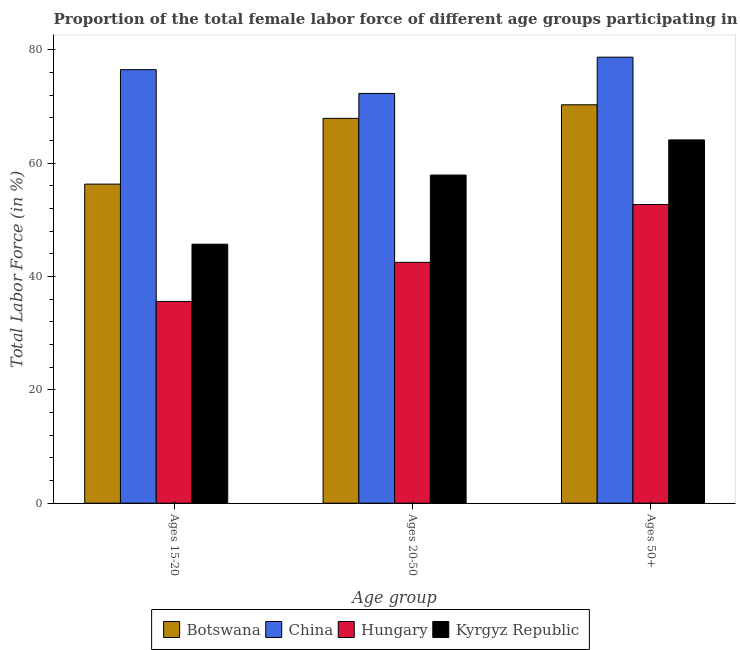How many different coloured bars are there?
Offer a terse response. 4. How many groups of bars are there?
Your answer should be very brief. 3. Are the number of bars per tick equal to the number of legend labels?
Provide a succinct answer. Yes. How many bars are there on the 1st tick from the right?
Offer a very short reply. 4. What is the label of the 1st group of bars from the left?
Your answer should be very brief. Ages 15-20. What is the percentage of female labor force above age 50 in China?
Offer a terse response. 78.7. Across all countries, what is the maximum percentage of female labor force above age 50?
Offer a terse response. 78.7. Across all countries, what is the minimum percentage of female labor force above age 50?
Your answer should be very brief. 52.7. In which country was the percentage of female labor force within the age group 15-20 maximum?
Provide a short and direct response. China. In which country was the percentage of female labor force within the age group 20-50 minimum?
Keep it short and to the point. Hungary. What is the total percentage of female labor force within the age group 15-20 in the graph?
Make the answer very short. 214.1. What is the difference between the percentage of female labor force within the age group 20-50 in Kyrgyz Republic and that in Hungary?
Keep it short and to the point. 15.4. What is the difference between the percentage of female labor force within the age group 20-50 in Kyrgyz Republic and the percentage of female labor force above age 50 in Hungary?
Your answer should be compact. 5.2. What is the average percentage of female labor force within the age group 20-50 per country?
Your answer should be very brief. 60.15. What is the difference between the percentage of female labor force above age 50 and percentage of female labor force within the age group 15-20 in Botswana?
Provide a succinct answer. 14. What is the ratio of the percentage of female labor force above age 50 in Kyrgyz Republic to that in Botswana?
Make the answer very short. 0.91. Is the percentage of female labor force within the age group 20-50 in Hungary less than that in Kyrgyz Republic?
Make the answer very short. Yes. What is the difference between the highest and the second highest percentage of female labor force above age 50?
Your answer should be compact. 8.4. What is the difference between the highest and the lowest percentage of female labor force above age 50?
Ensure brevity in your answer.  26. In how many countries, is the percentage of female labor force within the age group 20-50 greater than the average percentage of female labor force within the age group 20-50 taken over all countries?
Keep it short and to the point. 2. Is the sum of the percentage of female labor force within the age group 20-50 in Botswana and China greater than the maximum percentage of female labor force within the age group 15-20 across all countries?
Give a very brief answer. Yes. What does the 4th bar from the left in Ages 50+ represents?
Give a very brief answer. Kyrgyz Republic. What does the 3rd bar from the right in Ages 50+ represents?
Your response must be concise. China. How many countries are there in the graph?
Ensure brevity in your answer.  4. Does the graph contain any zero values?
Provide a succinct answer. No. How many legend labels are there?
Give a very brief answer. 4. How are the legend labels stacked?
Provide a short and direct response. Horizontal. What is the title of the graph?
Offer a very short reply. Proportion of the total female labor force of different age groups participating in production in 1994. Does "Cameroon" appear as one of the legend labels in the graph?
Provide a short and direct response. No. What is the label or title of the X-axis?
Your answer should be very brief. Age group. What is the Total Labor Force (in %) of Botswana in Ages 15-20?
Provide a succinct answer. 56.3. What is the Total Labor Force (in %) in China in Ages 15-20?
Give a very brief answer. 76.5. What is the Total Labor Force (in %) of Hungary in Ages 15-20?
Ensure brevity in your answer.  35.6. What is the Total Labor Force (in %) of Kyrgyz Republic in Ages 15-20?
Offer a terse response. 45.7. What is the Total Labor Force (in %) of Botswana in Ages 20-50?
Keep it short and to the point. 67.9. What is the Total Labor Force (in %) in China in Ages 20-50?
Give a very brief answer. 72.3. What is the Total Labor Force (in %) of Hungary in Ages 20-50?
Offer a terse response. 42.5. What is the Total Labor Force (in %) in Kyrgyz Republic in Ages 20-50?
Provide a short and direct response. 57.9. What is the Total Labor Force (in %) of Botswana in Ages 50+?
Provide a succinct answer. 70.3. What is the Total Labor Force (in %) in China in Ages 50+?
Ensure brevity in your answer.  78.7. What is the Total Labor Force (in %) in Hungary in Ages 50+?
Ensure brevity in your answer.  52.7. What is the Total Labor Force (in %) in Kyrgyz Republic in Ages 50+?
Provide a succinct answer. 64.1. Across all Age group, what is the maximum Total Labor Force (in %) of Botswana?
Your response must be concise. 70.3. Across all Age group, what is the maximum Total Labor Force (in %) in China?
Keep it short and to the point. 78.7. Across all Age group, what is the maximum Total Labor Force (in %) in Hungary?
Offer a terse response. 52.7. Across all Age group, what is the maximum Total Labor Force (in %) of Kyrgyz Republic?
Provide a short and direct response. 64.1. Across all Age group, what is the minimum Total Labor Force (in %) in Botswana?
Make the answer very short. 56.3. Across all Age group, what is the minimum Total Labor Force (in %) of China?
Make the answer very short. 72.3. Across all Age group, what is the minimum Total Labor Force (in %) in Hungary?
Offer a terse response. 35.6. Across all Age group, what is the minimum Total Labor Force (in %) of Kyrgyz Republic?
Your answer should be very brief. 45.7. What is the total Total Labor Force (in %) of Botswana in the graph?
Offer a terse response. 194.5. What is the total Total Labor Force (in %) of China in the graph?
Provide a short and direct response. 227.5. What is the total Total Labor Force (in %) in Hungary in the graph?
Your answer should be compact. 130.8. What is the total Total Labor Force (in %) of Kyrgyz Republic in the graph?
Provide a short and direct response. 167.7. What is the difference between the Total Labor Force (in %) of Hungary in Ages 15-20 and that in Ages 20-50?
Give a very brief answer. -6.9. What is the difference between the Total Labor Force (in %) of Kyrgyz Republic in Ages 15-20 and that in Ages 20-50?
Make the answer very short. -12.2. What is the difference between the Total Labor Force (in %) in China in Ages 15-20 and that in Ages 50+?
Your answer should be compact. -2.2. What is the difference between the Total Labor Force (in %) of Hungary in Ages 15-20 and that in Ages 50+?
Ensure brevity in your answer.  -17.1. What is the difference between the Total Labor Force (in %) of Kyrgyz Republic in Ages 15-20 and that in Ages 50+?
Your answer should be very brief. -18.4. What is the difference between the Total Labor Force (in %) in China in Ages 20-50 and that in Ages 50+?
Offer a terse response. -6.4. What is the difference between the Total Labor Force (in %) in Hungary in Ages 20-50 and that in Ages 50+?
Make the answer very short. -10.2. What is the difference between the Total Labor Force (in %) in Botswana in Ages 15-20 and the Total Labor Force (in %) in Kyrgyz Republic in Ages 20-50?
Your response must be concise. -1.6. What is the difference between the Total Labor Force (in %) of China in Ages 15-20 and the Total Labor Force (in %) of Kyrgyz Republic in Ages 20-50?
Give a very brief answer. 18.6. What is the difference between the Total Labor Force (in %) of Hungary in Ages 15-20 and the Total Labor Force (in %) of Kyrgyz Republic in Ages 20-50?
Make the answer very short. -22.3. What is the difference between the Total Labor Force (in %) in Botswana in Ages 15-20 and the Total Labor Force (in %) in China in Ages 50+?
Provide a succinct answer. -22.4. What is the difference between the Total Labor Force (in %) of Botswana in Ages 15-20 and the Total Labor Force (in %) of Hungary in Ages 50+?
Offer a terse response. 3.6. What is the difference between the Total Labor Force (in %) in Botswana in Ages 15-20 and the Total Labor Force (in %) in Kyrgyz Republic in Ages 50+?
Your response must be concise. -7.8. What is the difference between the Total Labor Force (in %) of China in Ages 15-20 and the Total Labor Force (in %) of Hungary in Ages 50+?
Provide a short and direct response. 23.8. What is the difference between the Total Labor Force (in %) of China in Ages 15-20 and the Total Labor Force (in %) of Kyrgyz Republic in Ages 50+?
Offer a terse response. 12.4. What is the difference between the Total Labor Force (in %) in Hungary in Ages 15-20 and the Total Labor Force (in %) in Kyrgyz Republic in Ages 50+?
Give a very brief answer. -28.5. What is the difference between the Total Labor Force (in %) of Botswana in Ages 20-50 and the Total Labor Force (in %) of China in Ages 50+?
Your answer should be compact. -10.8. What is the difference between the Total Labor Force (in %) in China in Ages 20-50 and the Total Labor Force (in %) in Hungary in Ages 50+?
Ensure brevity in your answer.  19.6. What is the difference between the Total Labor Force (in %) in Hungary in Ages 20-50 and the Total Labor Force (in %) in Kyrgyz Republic in Ages 50+?
Your answer should be compact. -21.6. What is the average Total Labor Force (in %) in Botswana per Age group?
Give a very brief answer. 64.83. What is the average Total Labor Force (in %) in China per Age group?
Give a very brief answer. 75.83. What is the average Total Labor Force (in %) in Hungary per Age group?
Your response must be concise. 43.6. What is the average Total Labor Force (in %) of Kyrgyz Republic per Age group?
Provide a succinct answer. 55.9. What is the difference between the Total Labor Force (in %) in Botswana and Total Labor Force (in %) in China in Ages 15-20?
Make the answer very short. -20.2. What is the difference between the Total Labor Force (in %) in Botswana and Total Labor Force (in %) in Hungary in Ages 15-20?
Offer a terse response. 20.7. What is the difference between the Total Labor Force (in %) in Botswana and Total Labor Force (in %) in Kyrgyz Republic in Ages 15-20?
Provide a succinct answer. 10.6. What is the difference between the Total Labor Force (in %) of China and Total Labor Force (in %) of Hungary in Ages 15-20?
Offer a terse response. 40.9. What is the difference between the Total Labor Force (in %) in China and Total Labor Force (in %) in Kyrgyz Republic in Ages 15-20?
Give a very brief answer. 30.8. What is the difference between the Total Labor Force (in %) in Botswana and Total Labor Force (in %) in China in Ages 20-50?
Your response must be concise. -4.4. What is the difference between the Total Labor Force (in %) of Botswana and Total Labor Force (in %) of Hungary in Ages 20-50?
Provide a succinct answer. 25.4. What is the difference between the Total Labor Force (in %) in Botswana and Total Labor Force (in %) in Kyrgyz Republic in Ages 20-50?
Provide a short and direct response. 10. What is the difference between the Total Labor Force (in %) in China and Total Labor Force (in %) in Hungary in Ages 20-50?
Your response must be concise. 29.8. What is the difference between the Total Labor Force (in %) in China and Total Labor Force (in %) in Kyrgyz Republic in Ages 20-50?
Provide a succinct answer. 14.4. What is the difference between the Total Labor Force (in %) of Hungary and Total Labor Force (in %) of Kyrgyz Republic in Ages 20-50?
Make the answer very short. -15.4. What is the difference between the Total Labor Force (in %) in Botswana and Total Labor Force (in %) in Hungary in Ages 50+?
Ensure brevity in your answer.  17.6. What is the difference between the Total Labor Force (in %) of China and Total Labor Force (in %) of Kyrgyz Republic in Ages 50+?
Provide a short and direct response. 14.6. What is the difference between the Total Labor Force (in %) of Hungary and Total Labor Force (in %) of Kyrgyz Republic in Ages 50+?
Provide a succinct answer. -11.4. What is the ratio of the Total Labor Force (in %) in Botswana in Ages 15-20 to that in Ages 20-50?
Make the answer very short. 0.83. What is the ratio of the Total Labor Force (in %) of China in Ages 15-20 to that in Ages 20-50?
Your answer should be very brief. 1.06. What is the ratio of the Total Labor Force (in %) of Hungary in Ages 15-20 to that in Ages 20-50?
Your response must be concise. 0.84. What is the ratio of the Total Labor Force (in %) in Kyrgyz Republic in Ages 15-20 to that in Ages 20-50?
Offer a very short reply. 0.79. What is the ratio of the Total Labor Force (in %) of Botswana in Ages 15-20 to that in Ages 50+?
Provide a succinct answer. 0.8. What is the ratio of the Total Labor Force (in %) in Hungary in Ages 15-20 to that in Ages 50+?
Your response must be concise. 0.68. What is the ratio of the Total Labor Force (in %) of Kyrgyz Republic in Ages 15-20 to that in Ages 50+?
Provide a short and direct response. 0.71. What is the ratio of the Total Labor Force (in %) in Botswana in Ages 20-50 to that in Ages 50+?
Keep it short and to the point. 0.97. What is the ratio of the Total Labor Force (in %) of China in Ages 20-50 to that in Ages 50+?
Your answer should be very brief. 0.92. What is the ratio of the Total Labor Force (in %) of Hungary in Ages 20-50 to that in Ages 50+?
Offer a very short reply. 0.81. What is the ratio of the Total Labor Force (in %) in Kyrgyz Republic in Ages 20-50 to that in Ages 50+?
Make the answer very short. 0.9. What is the difference between the highest and the second highest Total Labor Force (in %) of China?
Ensure brevity in your answer.  2.2. What is the difference between the highest and the lowest Total Labor Force (in %) in Botswana?
Your answer should be very brief. 14. What is the difference between the highest and the lowest Total Labor Force (in %) of China?
Keep it short and to the point. 6.4. What is the difference between the highest and the lowest Total Labor Force (in %) of Hungary?
Your response must be concise. 17.1. 